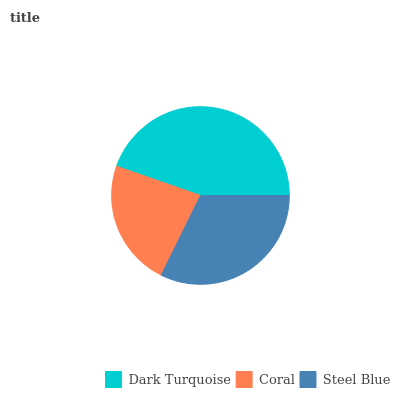Is Coral the minimum?
Answer yes or no. Yes. Is Dark Turquoise the maximum?
Answer yes or no. Yes. Is Steel Blue the minimum?
Answer yes or no. No. Is Steel Blue the maximum?
Answer yes or no. No. Is Steel Blue greater than Coral?
Answer yes or no. Yes. Is Coral less than Steel Blue?
Answer yes or no. Yes. Is Coral greater than Steel Blue?
Answer yes or no. No. Is Steel Blue less than Coral?
Answer yes or no. No. Is Steel Blue the high median?
Answer yes or no. Yes. Is Steel Blue the low median?
Answer yes or no. Yes. Is Coral the high median?
Answer yes or no. No. Is Dark Turquoise the low median?
Answer yes or no. No. 